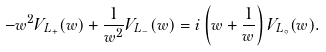Convert formula to latex. <formula><loc_0><loc_0><loc_500><loc_500>- w ^ { 2 } V _ { L _ { + } } ( w ) + \frac { 1 } { w ^ { 2 } } V _ { L _ { - } } ( w ) = i \left ( w + \frac { 1 } { w } \right ) V _ { L _ { \circ } } ( w ) .</formula> 